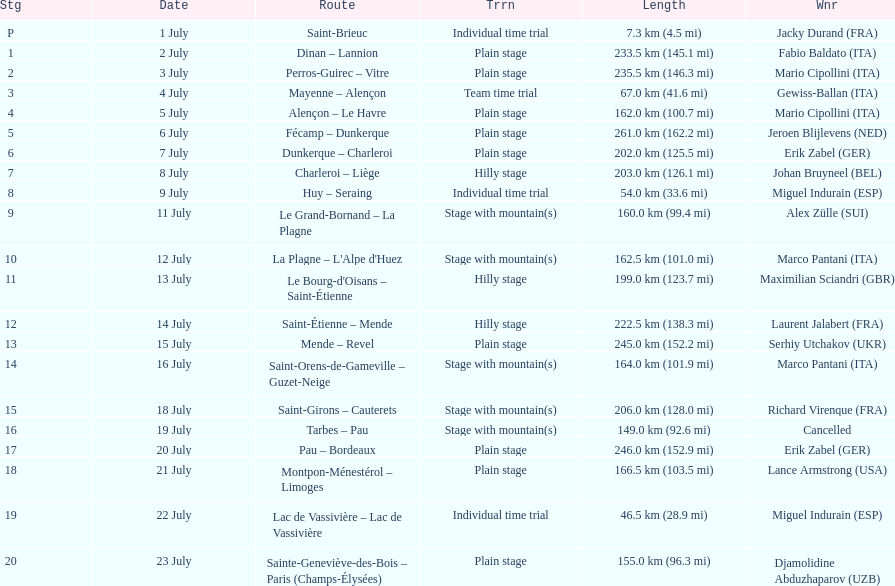Could you parse the entire table? {'header': ['Stg', 'Date', 'Route', 'Trrn', 'Length', 'Wnr'], 'rows': [['P', '1 July', 'Saint-Brieuc', 'Individual time trial', '7.3\xa0km (4.5\xa0mi)', 'Jacky Durand\xa0(FRA)'], ['1', '2 July', 'Dinan – Lannion', 'Plain stage', '233.5\xa0km (145.1\xa0mi)', 'Fabio Baldato\xa0(ITA)'], ['2', '3 July', 'Perros-Guirec – Vitre', 'Plain stage', '235.5\xa0km (146.3\xa0mi)', 'Mario Cipollini\xa0(ITA)'], ['3', '4 July', 'Mayenne – Alençon', 'Team time trial', '67.0\xa0km (41.6\xa0mi)', 'Gewiss-Ballan\xa0(ITA)'], ['4', '5 July', 'Alençon – Le Havre', 'Plain stage', '162.0\xa0km (100.7\xa0mi)', 'Mario Cipollini\xa0(ITA)'], ['5', '6 July', 'Fécamp – Dunkerque', 'Plain stage', '261.0\xa0km (162.2\xa0mi)', 'Jeroen Blijlevens\xa0(NED)'], ['6', '7 July', 'Dunkerque – Charleroi', 'Plain stage', '202.0\xa0km (125.5\xa0mi)', 'Erik Zabel\xa0(GER)'], ['7', '8 July', 'Charleroi – Liège', 'Hilly stage', '203.0\xa0km (126.1\xa0mi)', 'Johan Bruyneel\xa0(BEL)'], ['8', '9 July', 'Huy – Seraing', 'Individual time trial', '54.0\xa0km (33.6\xa0mi)', 'Miguel Indurain\xa0(ESP)'], ['9', '11 July', 'Le Grand-Bornand – La Plagne', 'Stage with mountain(s)', '160.0\xa0km (99.4\xa0mi)', 'Alex Zülle\xa0(SUI)'], ['10', '12 July', "La Plagne – L'Alpe d'Huez", 'Stage with mountain(s)', '162.5\xa0km (101.0\xa0mi)', 'Marco Pantani\xa0(ITA)'], ['11', '13 July', "Le Bourg-d'Oisans – Saint-Étienne", 'Hilly stage', '199.0\xa0km (123.7\xa0mi)', 'Maximilian Sciandri\xa0(GBR)'], ['12', '14 July', 'Saint-Étienne – Mende', 'Hilly stage', '222.5\xa0km (138.3\xa0mi)', 'Laurent Jalabert\xa0(FRA)'], ['13', '15 July', 'Mende – Revel', 'Plain stage', '245.0\xa0km (152.2\xa0mi)', 'Serhiy Utchakov\xa0(UKR)'], ['14', '16 July', 'Saint-Orens-de-Gameville – Guzet-Neige', 'Stage with mountain(s)', '164.0\xa0km (101.9\xa0mi)', 'Marco Pantani\xa0(ITA)'], ['15', '18 July', 'Saint-Girons – Cauterets', 'Stage with mountain(s)', '206.0\xa0km (128.0\xa0mi)', 'Richard Virenque\xa0(FRA)'], ['16', '19 July', 'Tarbes – Pau', 'Stage with mountain(s)', '149.0\xa0km (92.6\xa0mi)', 'Cancelled'], ['17', '20 July', 'Pau – Bordeaux', 'Plain stage', '246.0\xa0km (152.9\xa0mi)', 'Erik Zabel\xa0(GER)'], ['18', '21 July', 'Montpon-Ménestérol – Limoges', 'Plain stage', '166.5\xa0km (103.5\xa0mi)', 'Lance Armstrong\xa0(USA)'], ['19', '22 July', 'Lac de Vassivière – Lac de Vassivière', 'Individual time trial', '46.5\xa0km (28.9\xa0mi)', 'Miguel Indurain\xa0(ESP)'], ['20', '23 July', 'Sainte-Geneviève-des-Bois – Paris (Champs-Élysées)', 'Plain stage', '155.0\xa0km (96.3\xa0mi)', 'Djamolidine Abduzhaparov\xa0(UZB)']]} How many consecutive km were raced on july 8th? 203.0 km (126.1 mi). 